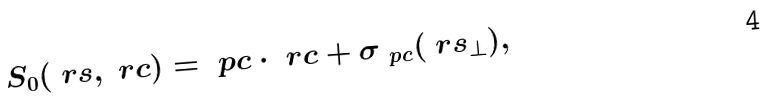Convert formula to latex. <formula><loc_0><loc_0><loc_500><loc_500>S _ { 0 } ( \ r s , \ r c ) = \ p c \cdot \ r c + \sigma _ { \ p c } ( \ r s _ { \bot } ) ,</formula> 